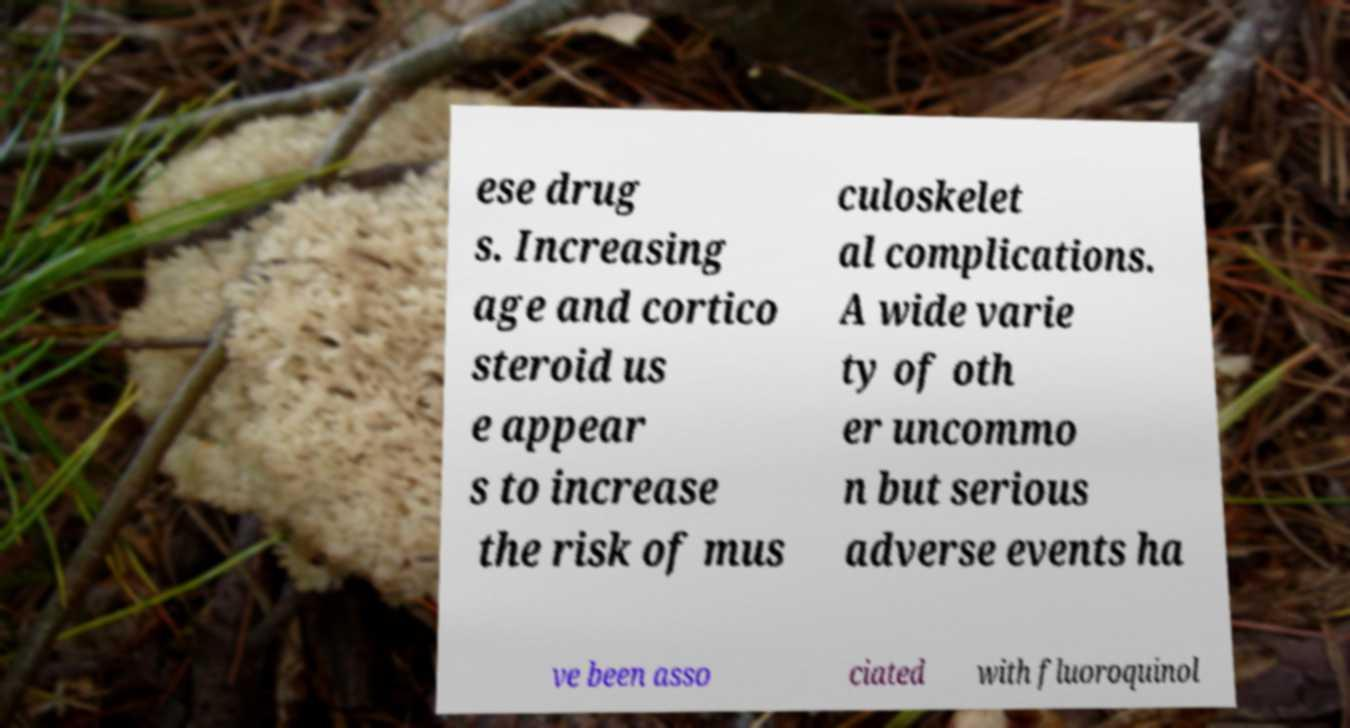Could you extract and type out the text from this image? ese drug s. Increasing age and cortico steroid us e appear s to increase the risk of mus culoskelet al complications. A wide varie ty of oth er uncommo n but serious adverse events ha ve been asso ciated with fluoroquinol 